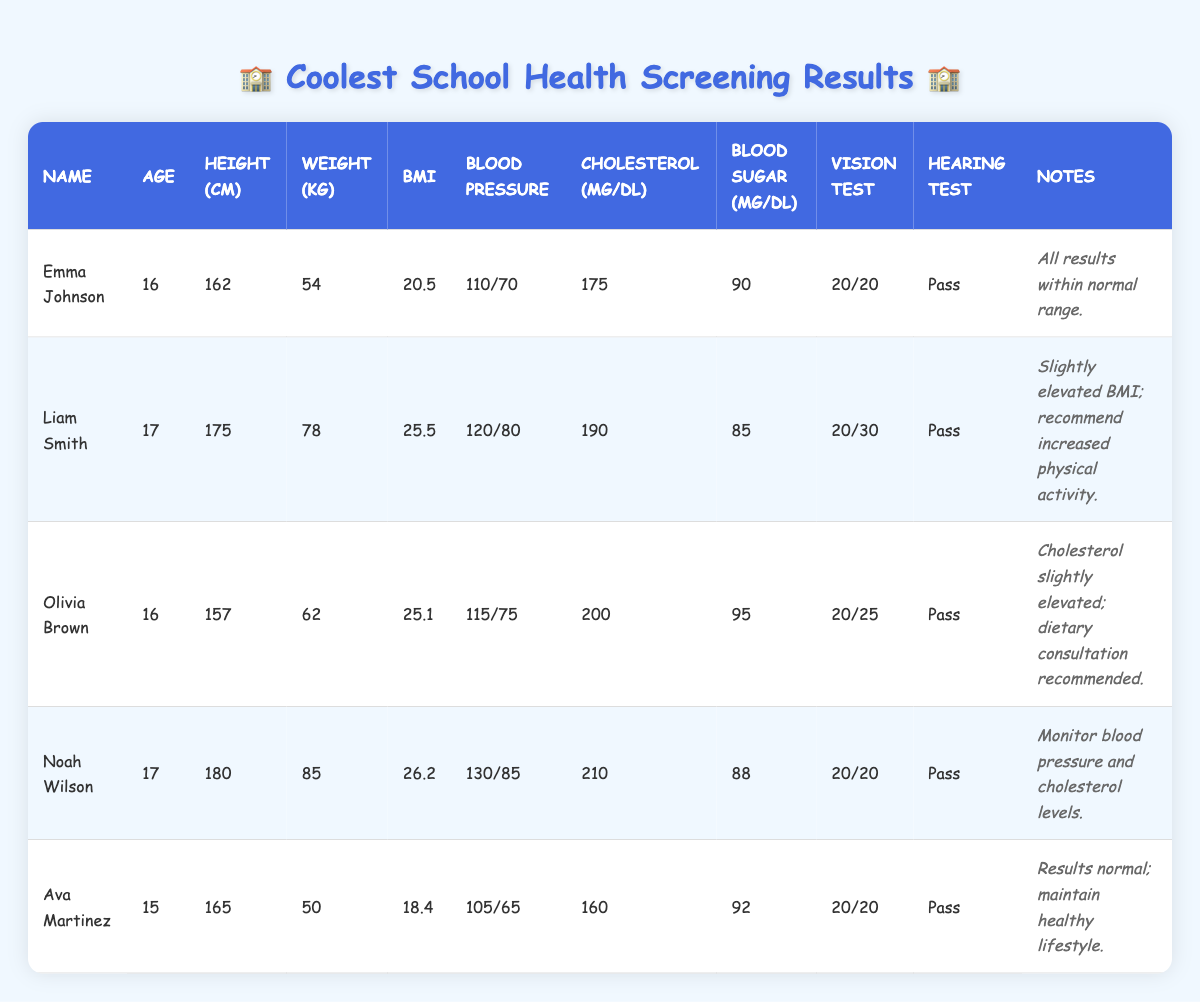What is the height of Noah Wilson? Noah Wilson's height is directly listed in the table under the height column. The height is specified in centimeters.
Answer: 180 cm Which student has the highest BMI? To find out which student has the highest BMI, we need to look at the BMI column and compare the values: Emma Johnson (20.5), Liam Smith (25.5), Olivia Brown (25.1), Noah Wilson (26.2), and Ava Martinez (18.4). The highest value is 26.2.
Answer: Noah Wilson Is Ava Martinez's blood pressure within the normal range? Normal blood pressure is generally considered to be around 120/80 or lower. Ava Martinez's blood pressure reading is 105/65 which is lower than this threshold, indicating that it is within a healthy range.
Answer: Yes What is the average age of the students? To find the average age, we sum the ages of all students: 16 + 17 + 16 + 17 + 15 = 81. Then, divide by the number of students (5): 81/5 = 16.2.
Answer: 16.2 Which students have a vision test result of 20/20? We can look through the vision test results column to identify students with a result of 20/20. The students with this result are Emma Johnson, Noah Wilson, and Ava Martinez.
Answer: Emma Johnson, Noah Wilson, Ava Martinez What percentage of students passed the hearing test? All students' hearing test results are listed as "Pass." To find the percentage, we take the total number of students who passed (5) divided by the total number of students (5) and multiply by 100: (5/5) * 100 = 100%.
Answer: 100% How many students have cholesterol levels above 200 mg/dL? We can look at the cholesterol column and identify the values: 175 (Emma), 190 (Liam), 200 (Olivia), 210 (Noah), and 160 (Ava). Only Noah Wilson has a cholesterol level above 200 mg/dL. Therefore, we have 1 student.
Answer: 1 What is the difference in weight between the heaviest and lightest students? The heaviest student is Noah Wilson at 85 kg and the lightest is Ava Martinez at 50 kg. To find the difference, we subtract the lighter weight from the heavier one: 85 - 50 = 35.
Answer: 35 kg What is the blood sugar range of the students? We review the blood sugar column to identify the minimum and maximum values: 85 (Liam) is the lowest and 95 (Olivia) is the highest. Thus, the blood sugar range starts from 85 mg/dL to 95 mg/dL.
Answer: 85 - 95 mg/dL 